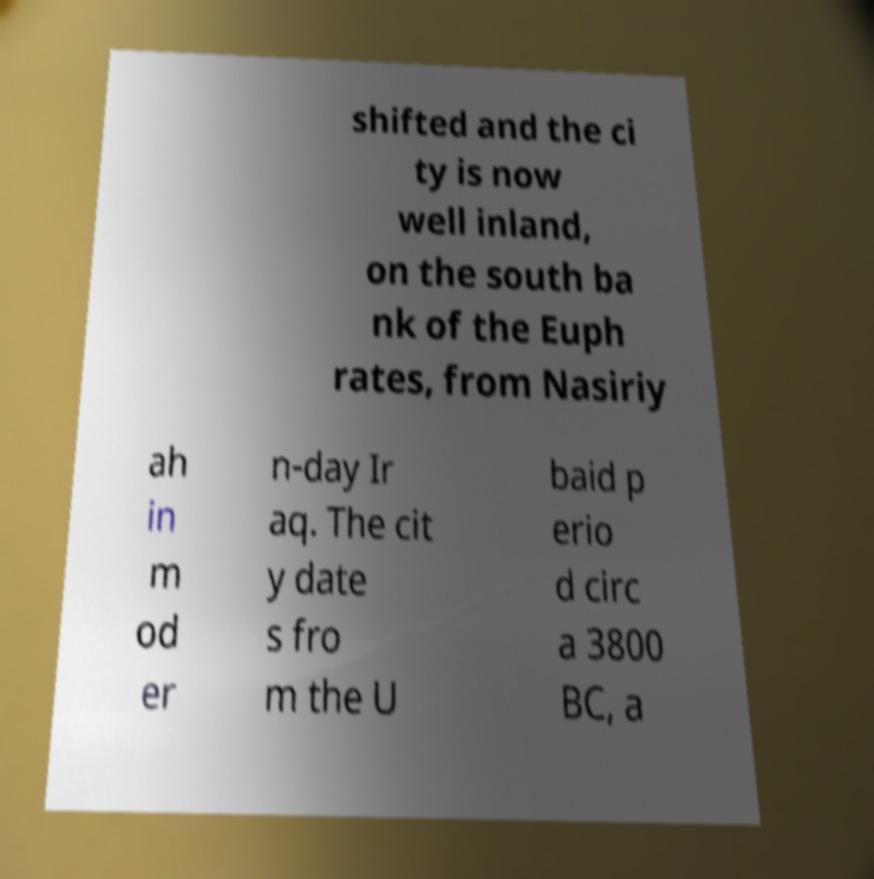Can you read and provide the text displayed in the image?This photo seems to have some interesting text. Can you extract and type it out for me? shifted and the ci ty is now well inland, on the south ba nk of the Euph rates, from Nasiriy ah in m od er n-day Ir aq. The cit y date s fro m the U baid p erio d circ a 3800 BC, a 